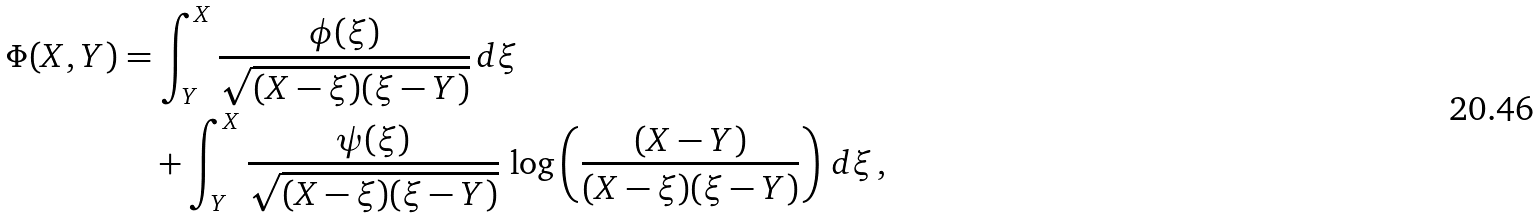Convert formula to latex. <formula><loc_0><loc_0><loc_500><loc_500>\Phi ( X , Y ) & = \int _ { Y } ^ { X } \frac { \phi ( \xi ) } { \sqrt { ( X - \xi ) ( \xi - Y ) } } \, d \xi \\ & \quad + \int _ { Y } ^ { X } \frac { \psi ( \xi ) } { \sqrt { ( X - \xi ) ( \xi - Y ) } } \, \log \left ( \frac { ( X - Y ) } { ( X - \xi ) ( \xi - Y ) } \right ) \, d \xi \, ,</formula> 